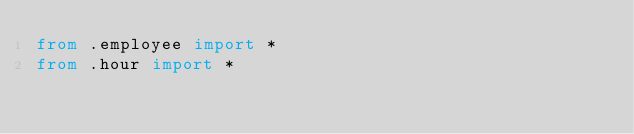Convert code to text. <code><loc_0><loc_0><loc_500><loc_500><_Python_>from .employee import *
from .hour import *
</code> 